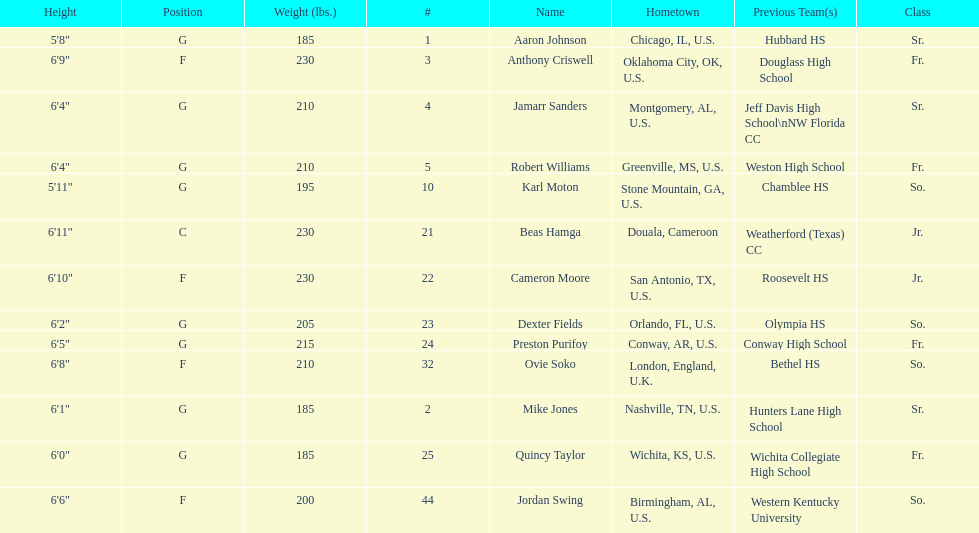What is the difference in weight between dexter fields and quincy taylor? 20. 